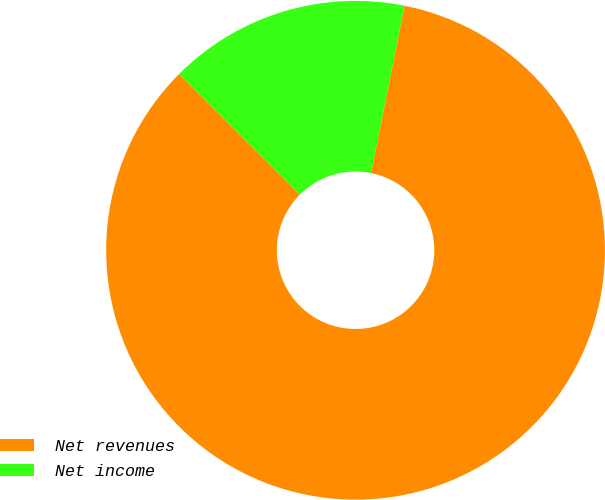<chart> <loc_0><loc_0><loc_500><loc_500><pie_chart><fcel>Net revenues<fcel>Net income<nl><fcel>84.34%<fcel>15.66%<nl></chart> 